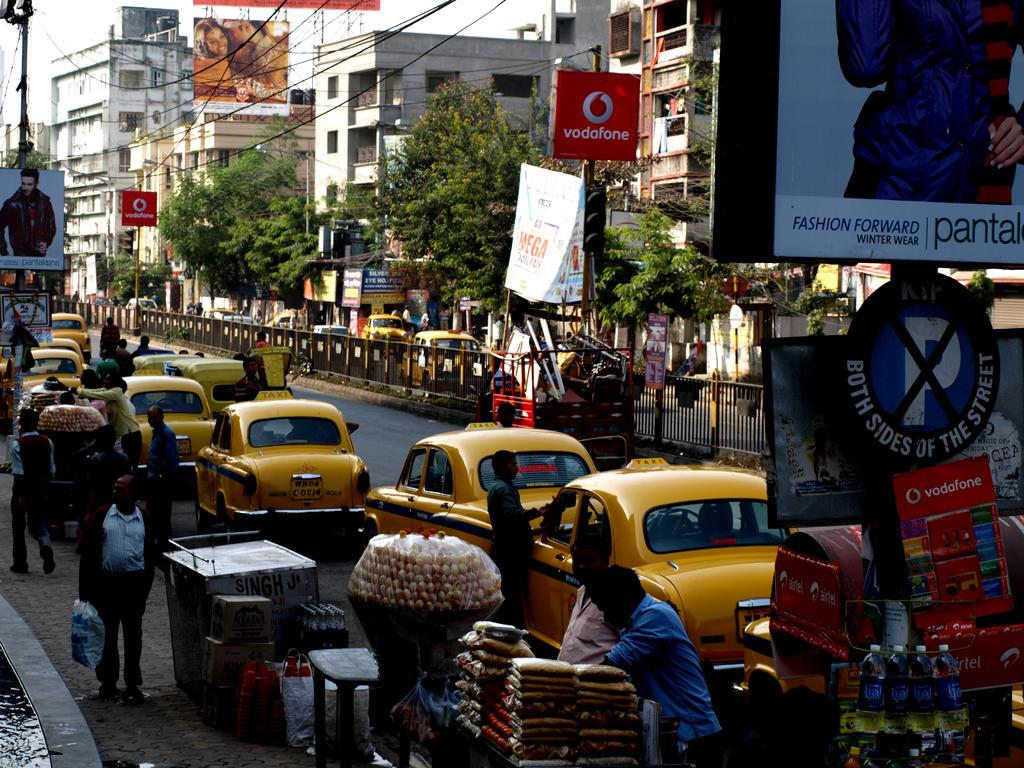<image>
Offer a succinct explanation of the picture presented. A busy street with a lot of taxis and a billboard sign saying Fashion Forward 